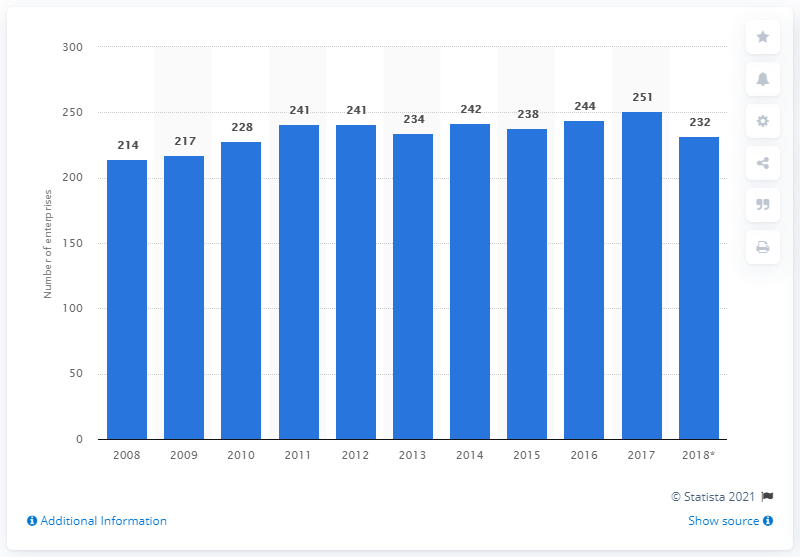Mention a couple of crucial points in this snapshot. There were 232 enterprises operating in the cocoa, chocolate, and sugar confectionery industry in Sweden in 2018. 